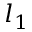Convert formula to latex. <formula><loc_0><loc_0><loc_500><loc_500>l _ { 1 }</formula> 